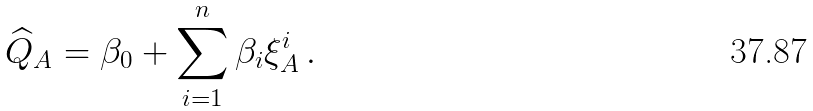<formula> <loc_0><loc_0><loc_500><loc_500>\widehat { Q } _ { A } = \beta _ { 0 } + \sum _ { i = 1 } ^ { n } \beta _ { i } \xi _ { A } ^ { i } \, .</formula> 